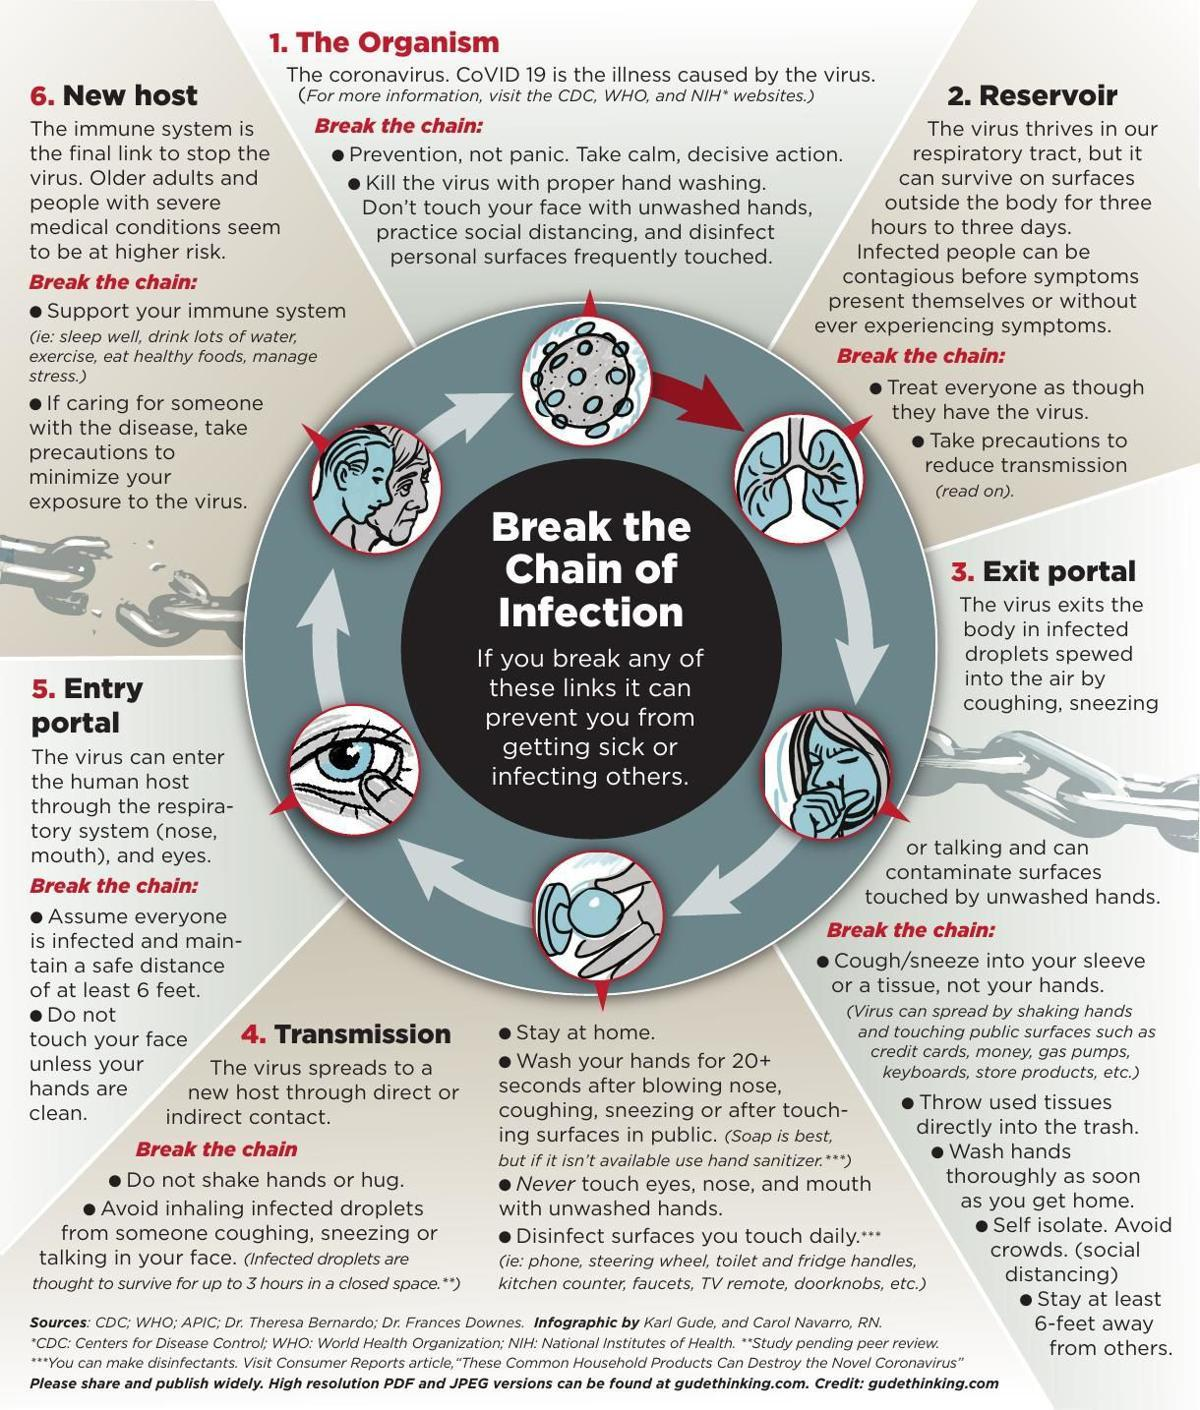Give some essential details in this illustration. The second bullet point given under the fifth subtopic is "Do not touch your face unless your hands are clean. The second last bullet point given under the third subtopic is "self-isolate. avoid crowds. (social distancing).. The second topic presented in this infographic is 'reservoir.' The third topic given in the infographic is "exit portal. The third bullet point under the fourth subtopic is 'stay at home.' 